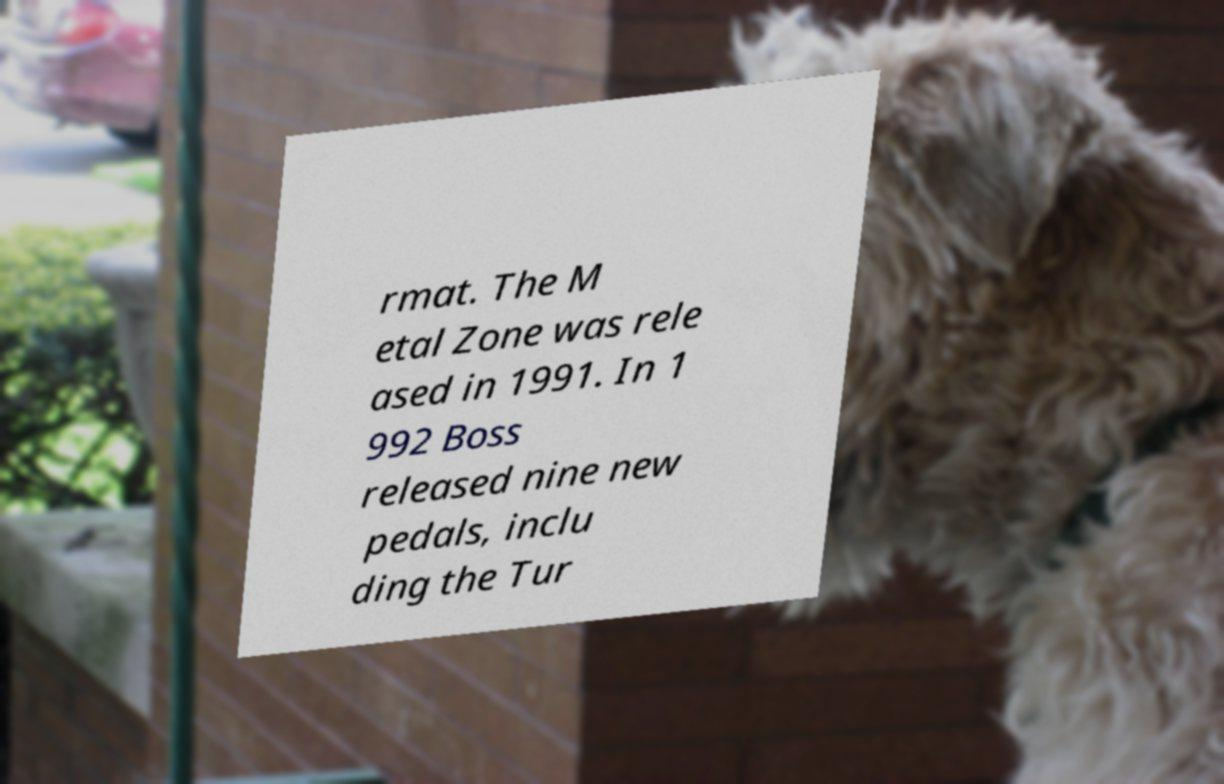Please identify and transcribe the text found in this image. rmat. The M etal Zone was rele ased in 1991. In 1 992 Boss released nine new pedals, inclu ding the Tur 